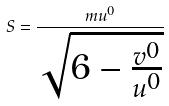<formula> <loc_0><loc_0><loc_500><loc_500>S = \frac { m u ^ { 0 } } { \sqrt { 6 - \frac { v ^ { 0 } } { u ^ { 0 } } } }</formula> 